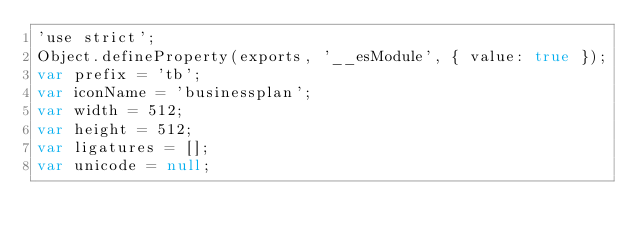Convert code to text. <code><loc_0><loc_0><loc_500><loc_500><_JavaScript_>'use strict';
Object.defineProperty(exports, '__esModule', { value: true });
var prefix = 'tb';
var iconName = 'businessplan';
var width = 512;
var height = 512;
var ligatures = [];
var unicode = null;</code> 